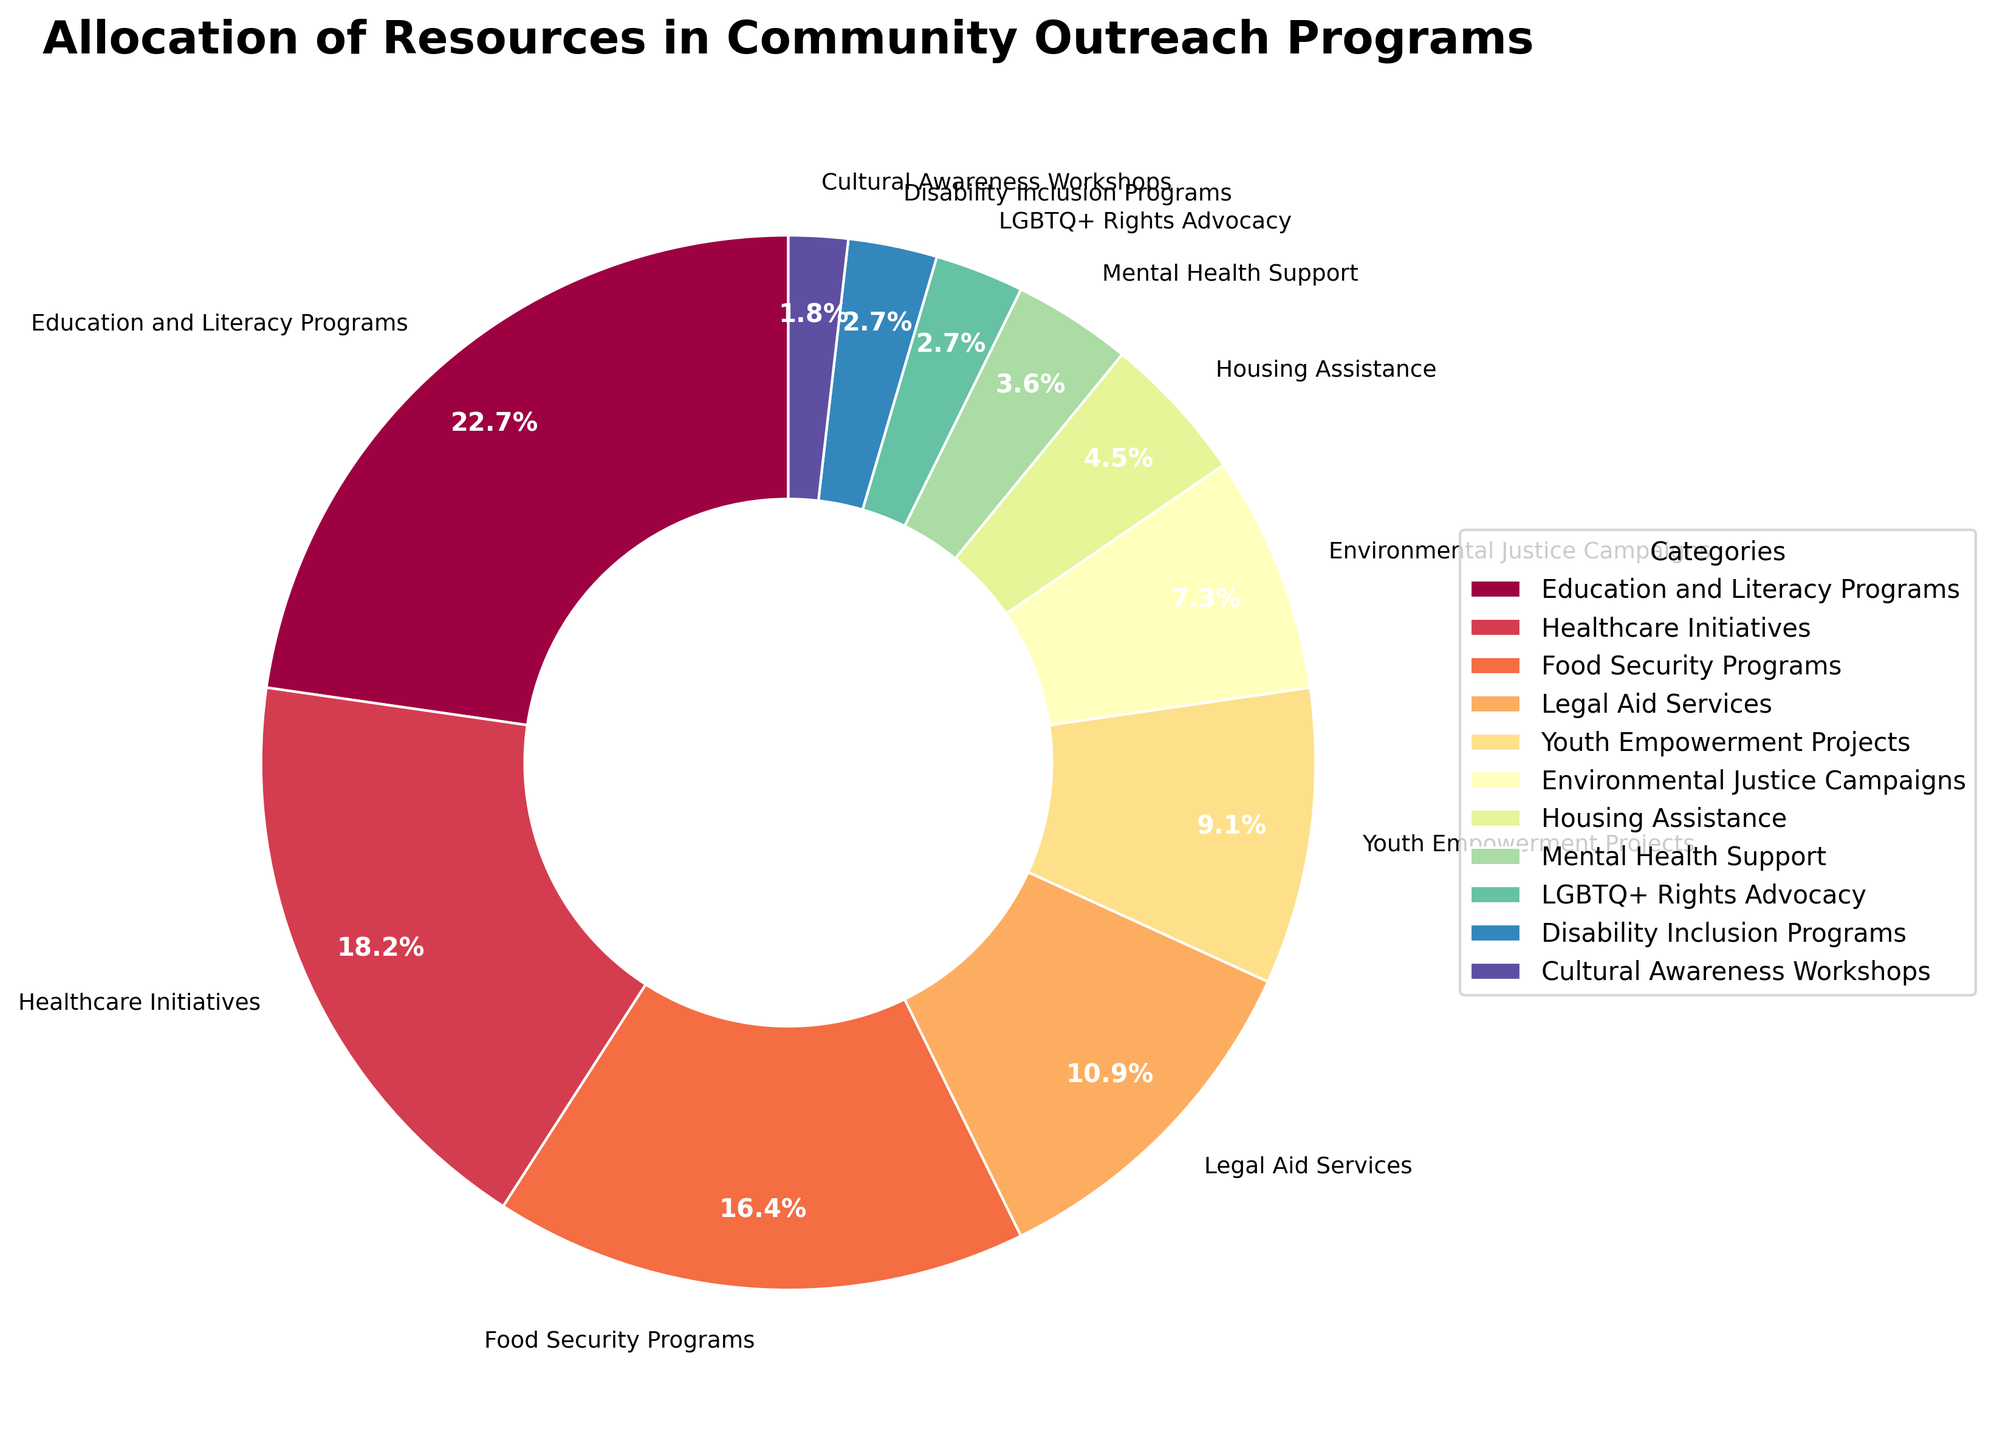What percentage of the total resources is allocated to Healthcare Initiatives and Food Security Programs combined? Add the percentages for Healthcare Initiatives (20%) and Food Security Programs (18%) together. 20% + 18% = 38%.
Answer: 38% Which category receives the smallest allocation of resources? Look for the category with the smallest percentage in the pie chart. Disability Inclusion Programs and Cultural Awareness Workshops both receive the smallest allocation at 3% and 2%, respectively. Therefore, Cultural Awareness Workshops receive the smallest allocation.
Answer: Cultural Awareness Workshops Among Education and Literacy Programs and Environmental Justice Campaigns, which category has the higher allocation of resources, and by how much? Compare the percentages for Education and Literacy Programs (25%) and Environmental Justice Campaigns (8%). Subtract 8% from 25% to find the difference. 25% - 8% = 17%.
Answer: Education and Literacy Programs, by 17% What's the total percentage of resources allocated to Youth Empowerment Projects, Legal Aid Services, and Mental Health Support combined? Add the percentages for Youth Empowerment Projects (10%), Legal Aid Services (12%), and Mental Health Support (4%). 10% + 12% + 4% = 26%.
Answer: 26% What is the dominant color for the Healthcare Initiatives wedge in the pie chart? Identify the color of the wedge representing Healthcare Initiatives in the pie chart. The colors are generated using a spectral colormap, and Healthcare Initiatives represent the second segment (likely to be a shade of orange or red).
Answer: Likely orange or red (depends on the specific spectre scale used) Which category receives slightly more resources, Legal Aid Services or Youth Empowerment Projects, and by what percentage? Compare the percentages for Legal Aid Services (12%) and Youth Empowerment Projects (10%). Subtract 10% from 12% to determine the difference. 12% - 10% = 2%.
Answer: Legal Aid Services, by 2% How does the allocation to Food Security Programs compare to the allocation to Housing Assistance? Compare the percentages for Food Security Programs (18%) and Housing Assistance (5%). Food Security Programs have a higher percentage than Housing Assistance.
Answer: Food Security Programs receive more resources than Housing Assistance What are the top three categories receiving the highest allocation of resources? Identify the top three categories based on the largest percentages. Education and Literacy Programs (25%), Healthcare Initiatives (20%), and Food Security Programs (18%) are the top three.
Answer: Education and Literacy Programs, Healthcare Initiatives, Food Security Programs What is the difference in resource allocation between the category receiving the most resources and the category receiving the least resources? Compare the percentages of the category receiving the most (Education and Literacy Programs at 25%) and the least (Cultural Awareness Workshops at 2%). Subtract 2% from 25%. 25% - 2% = 23%.
Answer: 23% What's the combined percentage for the categories receiving 10% or less of the resources? Sum the percentages for Youth Empowerment Projects (10%), Environmental Justice Campaigns (8%), Housing Assistance (5%), Mental Health Support (4%), LGBTQ+ Rights Advocacy (3%), Disability Inclusion Programs (3%), and Cultural Awareness Workshops (2%). 10% + 8% + 5% + 4% + 3% + 3% + 2% = 35%.
Answer: 35% 